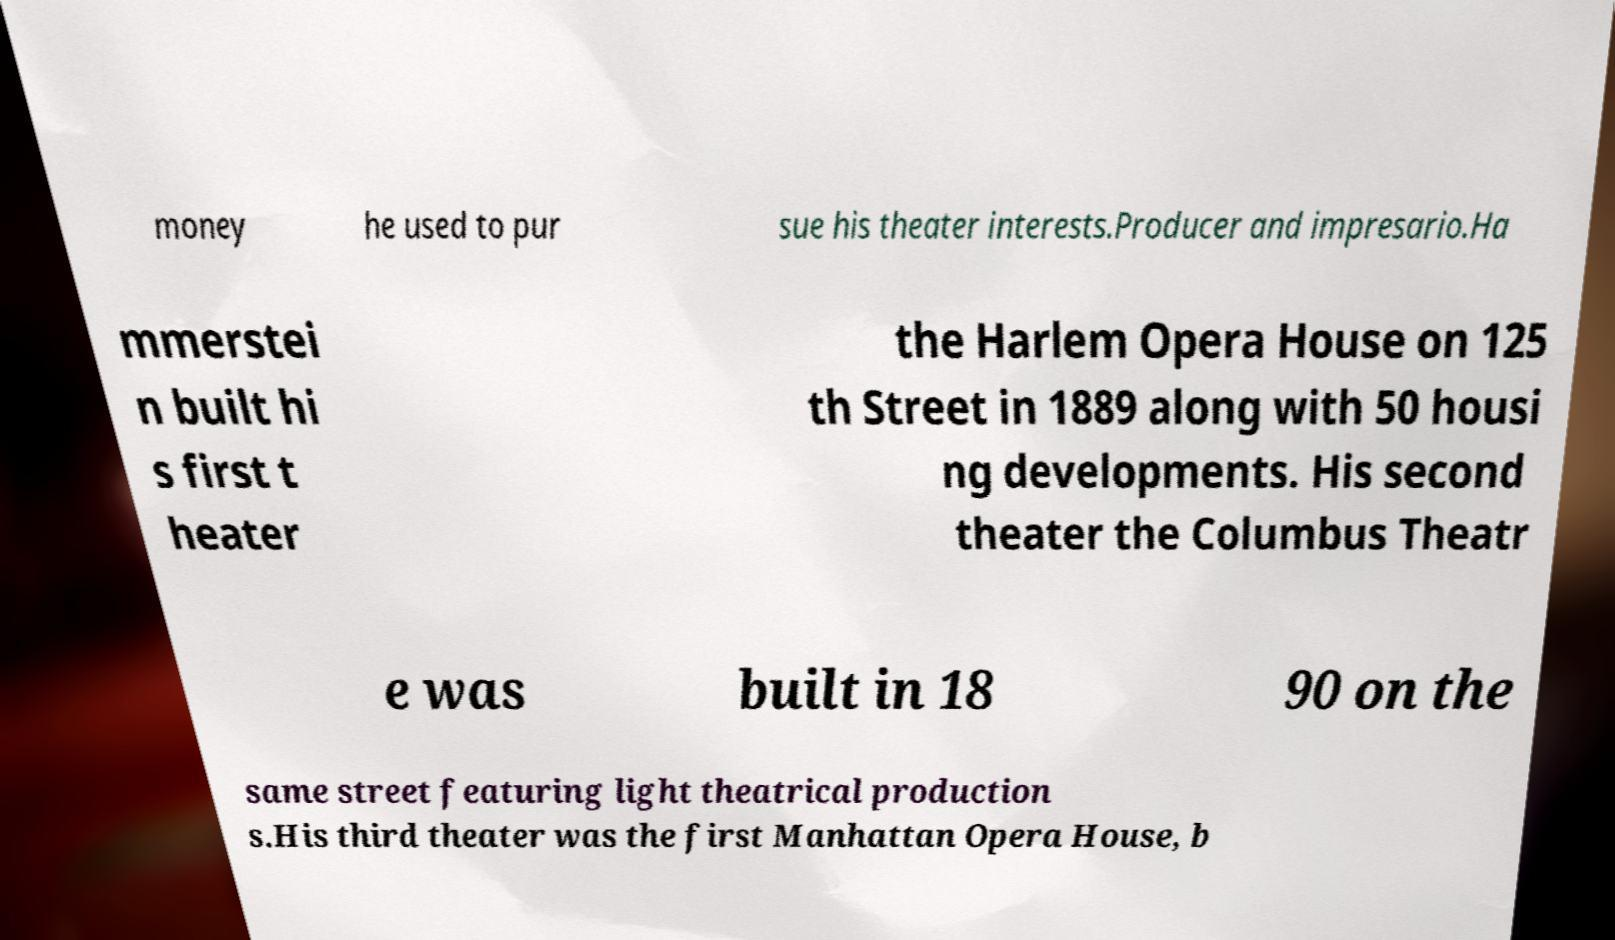Please read and relay the text visible in this image. What does it say? money he used to pur sue his theater interests.Producer and impresario.Ha mmerstei n built hi s first t heater the Harlem Opera House on 125 th Street in 1889 along with 50 housi ng developments. His second theater the Columbus Theatr e was built in 18 90 on the same street featuring light theatrical production s.His third theater was the first Manhattan Opera House, b 